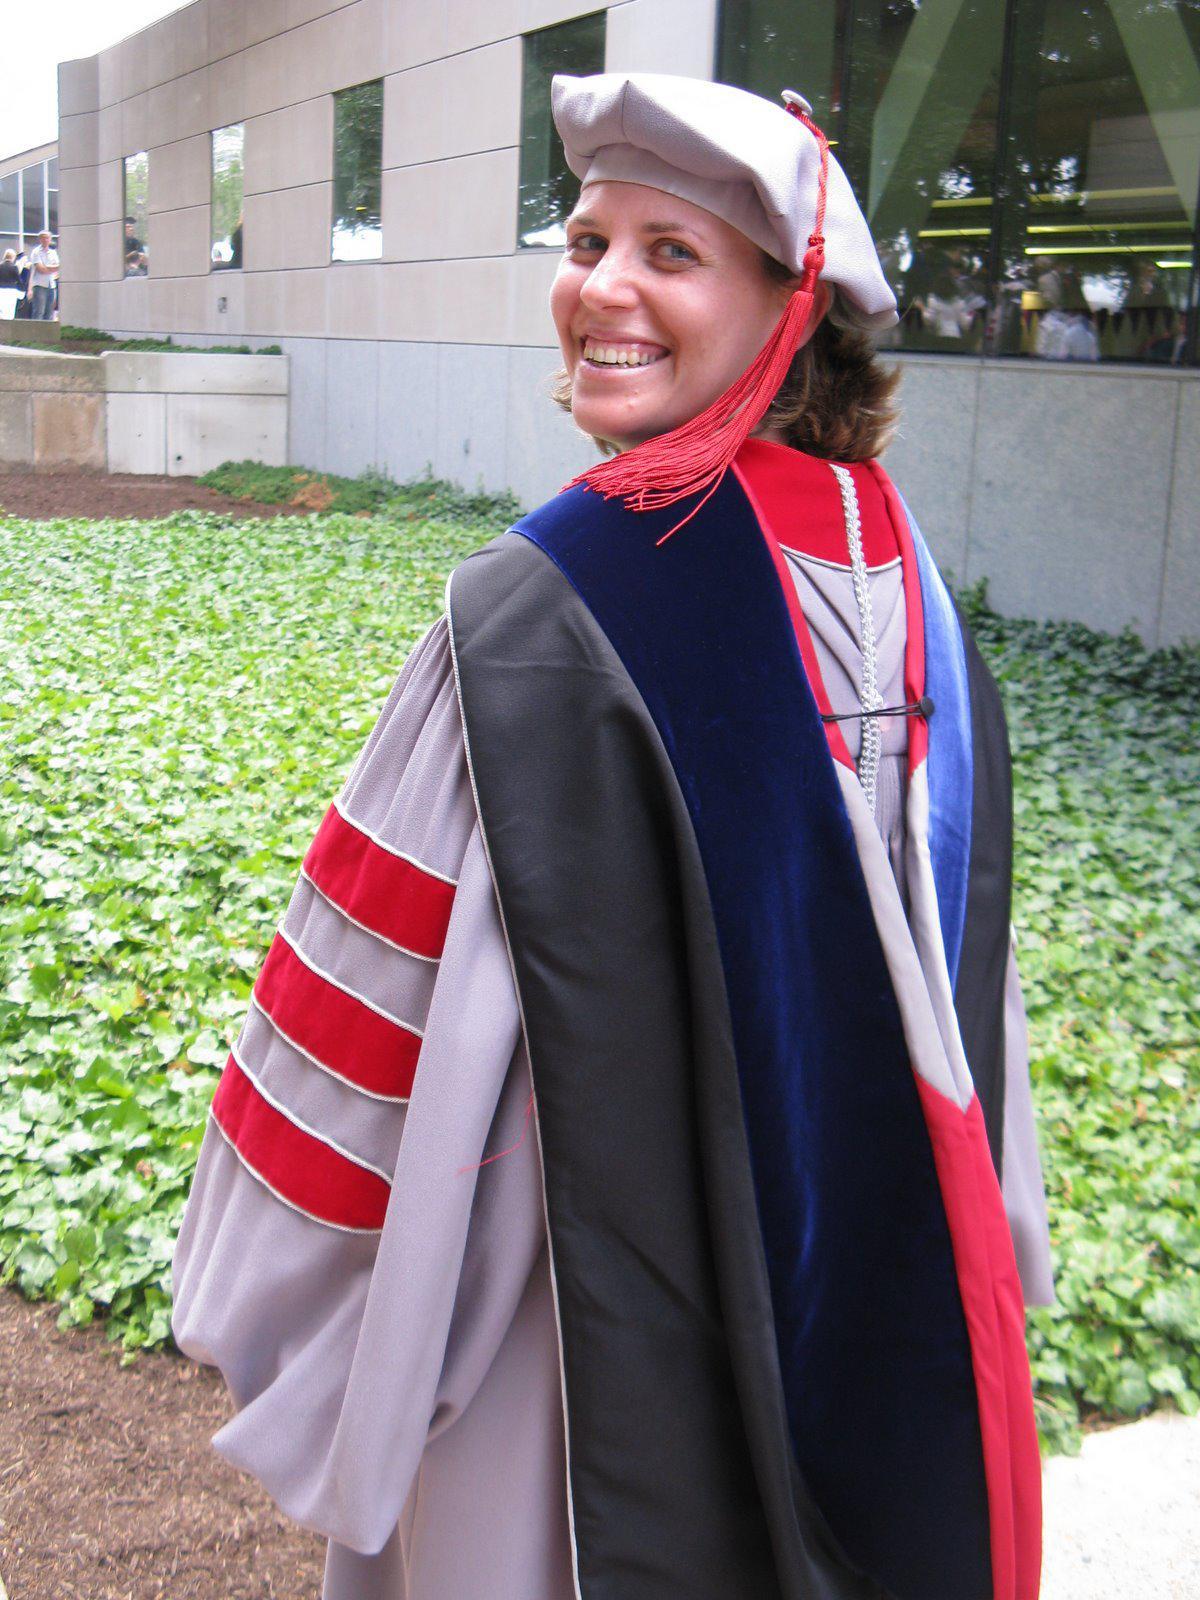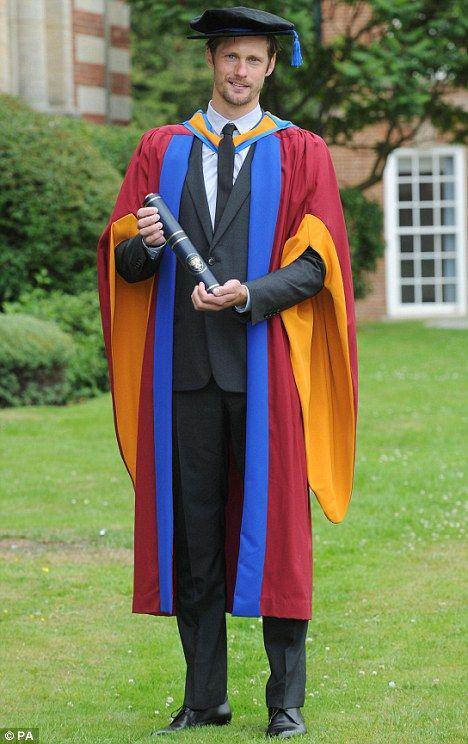The first image is the image on the left, the second image is the image on the right. For the images displayed, is the sentence "No graduate wears glasses, and the graduate in the right image is a male, while the graduate in the left image is female." factually correct? Answer yes or no. Yes. The first image is the image on the left, the second image is the image on the right. Assess this claim about the two images: "Two people, one man and one woman, wearing graduation gowns and caps, each a different style, are seen facing front in full length photos.". Correct or not? Answer yes or no. No. 